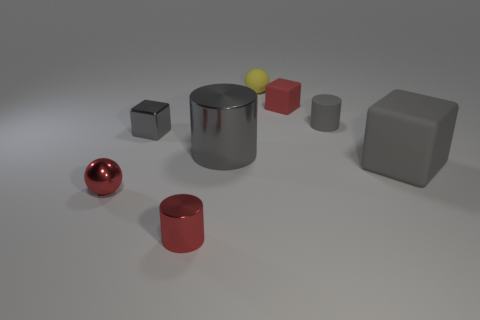Subtract all shiny cylinders. How many cylinders are left? 1 Subtract all cyan blocks. How many gray cylinders are left? 2 Subtract 1 cylinders. How many cylinders are left? 2 Add 2 tiny matte blocks. How many objects exist? 10 Subtract all cubes. How many objects are left? 5 Subtract all cyan cylinders. Subtract all gray balls. How many cylinders are left? 3 Subtract 1 gray cylinders. How many objects are left? 7 Subtract all large gray objects. Subtract all matte balls. How many objects are left? 5 Add 6 yellow rubber spheres. How many yellow rubber spheres are left? 7 Add 5 cyan shiny cubes. How many cyan shiny cubes exist? 5 